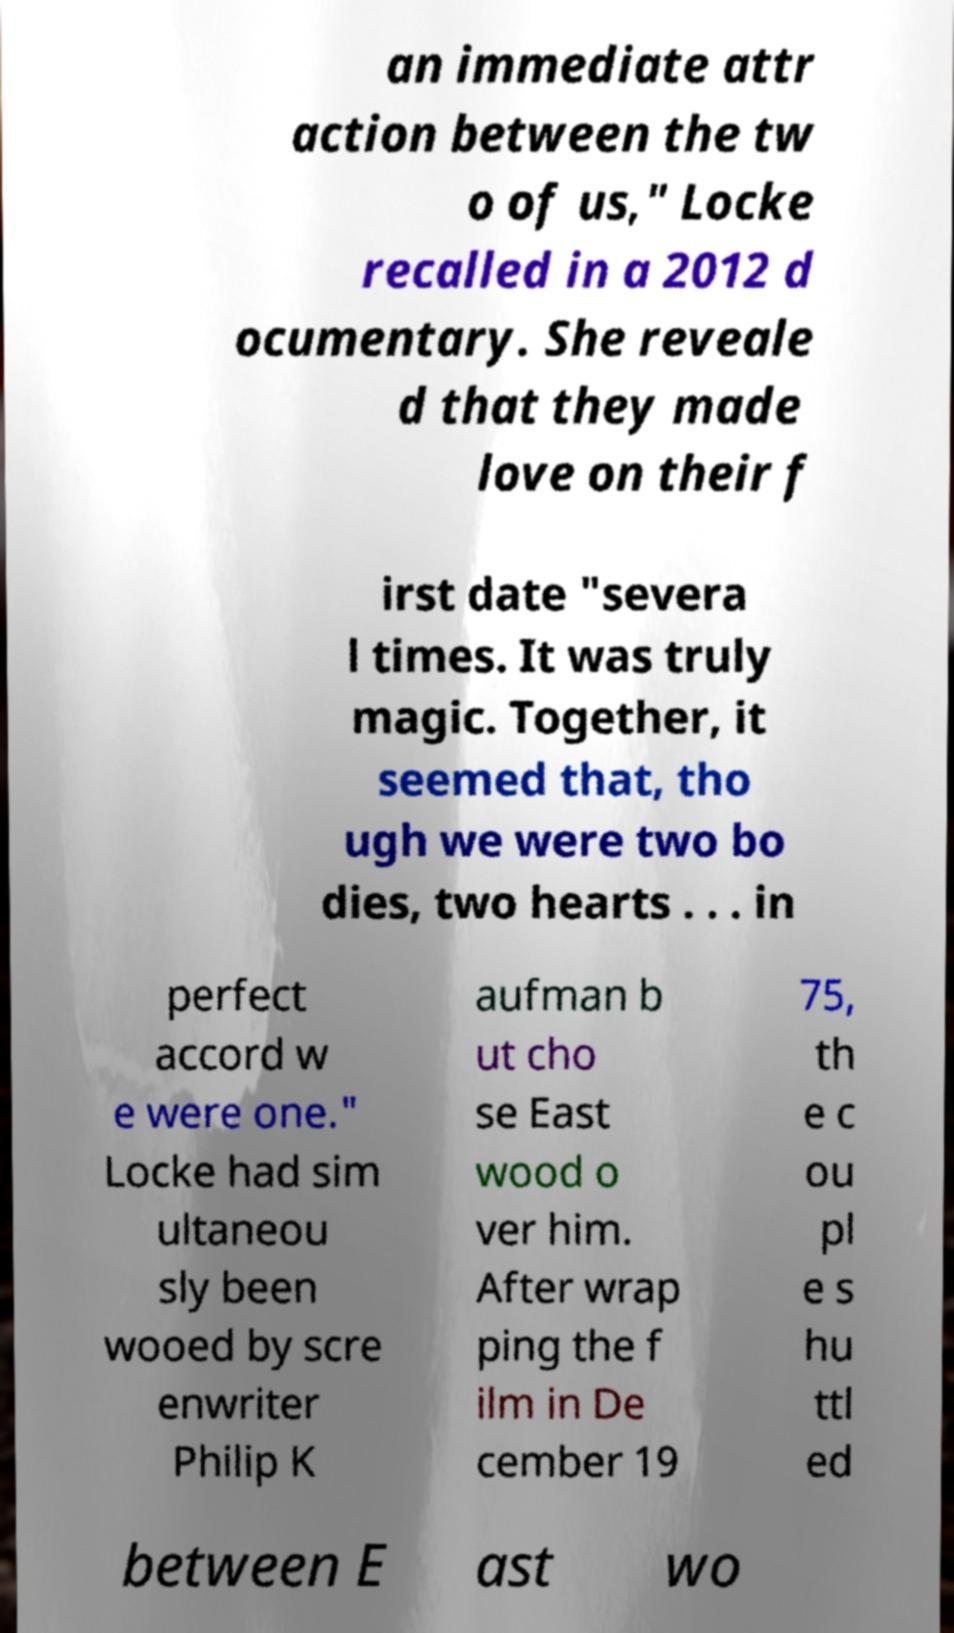Can you accurately transcribe the text from the provided image for me? an immediate attr action between the tw o of us," Locke recalled in a 2012 d ocumentary. She reveale d that they made love on their f irst date "severa l times. It was truly magic. Together, it seemed that, tho ugh we were two bo dies, two hearts . . . in perfect accord w e were one." Locke had sim ultaneou sly been wooed by scre enwriter Philip K aufman b ut cho se East wood o ver him. After wrap ping the f ilm in De cember 19 75, th e c ou pl e s hu ttl ed between E ast wo 